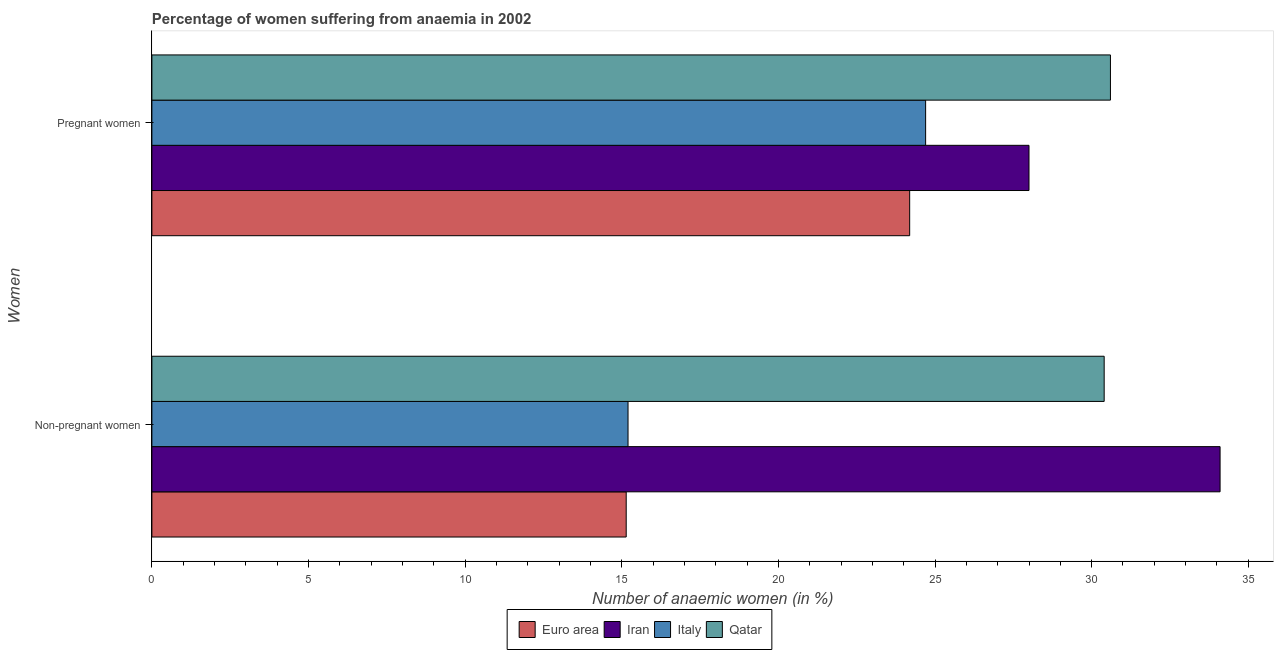How many different coloured bars are there?
Ensure brevity in your answer.  4. What is the label of the 2nd group of bars from the top?
Ensure brevity in your answer.  Non-pregnant women. What is the percentage of non-pregnant anaemic women in Italy?
Provide a short and direct response. 15.2. Across all countries, what is the maximum percentage of pregnant anaemic women?
Offer a terse response. 30.6. Across all countries, what is the minimum percentage of non-pregnant anaemic women?
Ensure brevity in your answer.  15.14. In which country was the percentage of non-pregnant anaemic women maximum?
Keep it short and to the point. Iran. In which country was the percentage of non-pregnant anaemic women minimum?
Provide a succinct answer. Euro area. What is the total percentage of non-pregnant anaemic women in the graph?
Give a very brief answer. 94.84. What is the difference between the percentage of non-pregnant anaemic women in Iran and that in Qatar?
Provide a succinct answer. 3.7. What is the difference between the percentage of non-pregnant anaemic women in Qatar and the percentage of pregnant anaemic women in Euro area?
Your answer should be compact. 6.21. What is the average percentage of non-pregnant anaemic women per country?
Offer a very short reply. 23.71. What is the difference between the percentage of non-pregnant anaemic women and percentage of pregnant anaemic women in Qatar?
Make the answer very short. -0.2. What is the ratio of the percentage of non-pregnant anaemic women in Euro area to that in Qatar?
Provide a succinct answer. 0.5. Is the percentage of pregnant anaemic women in Euro area less than that in Iran?
Your answer should be very brief. Yes. What does the 3rd bar from the top in Non-pregnant women represents?
Your answer should be very brief. Iran. What does the 2nd bar from the bottom in Non-pregnant women represents?
Offer a terse response. Iran. Are all the bars in the graph horizontal?
Provide a succinct answer. Yes. What is the difference between two consecutive major ticks on the X-axis?
Your answer should be compact. 5. Are the values on the major ticks of X-axis written in scientific E-notation?
Ensure brevity in your answer.  No. Where does the legend appear in the graph?
Ensure brevity in your answer.  Bottom center. How are the legend labels stacked?
Offer a very short reply. Horizontal. What is the title of the graph?
Your response must be concise. Percentage of women suffering from anaemia in 2002. Does "Mali" appear as one of the legend labels in the graph?
Ensure brevity in your answer.  No. What is the label or title of the X-axis?
Your answer should be compact. Number of anaemic women (in %). What is the label or title of the Y-axis?
Your response must be concise. Women. What is the Number of anaemic women (in %) of Euro area in Non-pregnant women?
Provide a succinct answer. 15.14. What is the Number of anaemic women (in %) of Iran in Non-pregnant women?
Give a very brief answer. 34.1. What is the Number of anaemic women (in %) of Italy in Non-pregnant women?
Your response must be concise. 15.2. What is the Number of anaemic women (in %) in Qatar in Non-pregnant women?
Your response must be concise. 30.4. What is the Number of anaemic women (in %) in Euro area in Pregnant women?
Your response must be concise. 24.19. What is the Number of anaemic women (in %) in Iran in Pregnant women?
Provide a succinct answer. 28. What is the Number of anaemic women (in %) of Italy in Pregnant women?
Ensure brevity in your answer.  24.7. What is the Number of anaemic women (in %) of Qatar in Pregnant women?
Make the answer very short. 30.6. Across all Women, what is the maximum Number of anaemic women (in %) in Euro area?
Provide a succinct answer. 24.19. Across all Women, what is the maximum Number of anaemic women (in %) in Iran?
Offer a very short reply. 34.1. Across all Women, what is the maximum Number of anaemic women (in %) in Italy?
Keep it short and to the point. 24.7. Across all Women, what is the maximum Number of anaemic women (in %) in Qatar?
Your response must be concise. 30.6. Across all Women, what is the minimum Number of anaemic women (in %) in Euro area?
Offer a very short reply. 15.14. Across all Women, what is the minimum Number of anaemic women (in %) of Iran?
Ensure brevity in your answer.  28. Across all Women, what is the minimum Number of anaemic women (in %) in Qatar?
Give a very brief answer. 30.4. What is the total Number of anaemic women (in %) of Euro area in the graph?
Provide a succinct answer. 39.33. What is the total Number of anaemic women (in %) in Iran in the graph?
Keep it short and to the point. 62.1. What is the total Number of anaemic women (in %) of Italy in the graph?
Offer a terse response. 39.9. What is the total Number of anaemic women (in %) of Qatar in the graph?
Your answer should be compact. 61. What is the difference between the Number of anaemic women (in %) in Euro area in Non-pregnant women and that in Pregnant women?
Ensure brevity in your answer.  -9.05. What is the difference between the Number of anaemic women (in %) of Italy in Non-pregnant women and that in Pregnant women?
Make the answer very short. -9.5. What is the difference between the Number of anaemic women (in %) in Qatar in Non-pregnant women and that in Pregnant women?
Your response must be concise. -0.2. What is the difference between the Number of anaemic women (in %) of Euro area in Non-pregnant women and the Number of anaemic women (in %) of Iran in Pregnant women?
Offer a very short reply. -12.86. What is the difference between the Number of anaemic women (in %) in Euro area in Non-pregnant women and the Number of anaemic women (in %) in Italy in Pregnant women?
Give a very brief answer. -9.56. What is the difference between the Number of anaemic women (in %) of Euro area in Non-pregnant women and the Number of anaemic women (in %) of Qatar in Pregnant women?
Provide a succinct answer. -15.46. What is the difference between the Number of anaemic women (in %) in Iran in Non-pregnant women and the Number of anaemic women (in %) in Qatar in Pregnant women?
Make the answer very short. 3.5. What is the difference between the Number of anaemic women (in %) in Italy in Non-pregnant women and the Number of anaemic women (in %) in Qatar in Pregnant women?
Give a very brief answer. -15.4. What is the average Number of anaemic women (in %) in Euro area per Women?
Your answer should be compact. 19.67. What is the average Number of anaemic women (in %) of Iran per Women?
Offer a very short reply. 31.05. What is the average Number of anaemic women (in %) of Italy per Women?
Give a very brief answer. 19.95. What is the average Number of anaemic women (in %) of Qatar per Women?
Provide a short and direct response. 30.5. What is the difference between the Number of anaemic women (in %) in Euro area and Number of anaemic women (in %) in Iran in Non-pregnant women?
Provide a short and direct response. -18.96. What is the difference between the Number of anaemic women (in %) of Euro area and Number of anaemic women (in %) of Italy in Non-pregnant women?
Offer a very short reply. -0.06. What is the difference between the Number of anaemic women (in %) in Euro area and Number of anaemic women (in %) in Qatar in Non-pregnant women?
Ensure brevity in your answer.  -15.26. What is the difference between the Number of anaemic women (in %) in Italy and Number of anaemic women (in %) in Qatar in Non-pregnant women?
Offer a very short reply. -15.2. What is the difference between the Number of anaemic women (in %) in Euro area and Number of anaemic women (in %) in Iran in Pregnant women?
Give a very brief answer. -3.81. What is the difference between the Number of anaemic women (in %) of Euro area and Number of anaemic women (in %) of Italy in Pregnant women?
Keep it short and to the point. -0.51. What is the difference between the Number of anaemic women (in %) in Euro area and Number of anaemic women (in %) in Qatar in Pregnant women?
Offer a very short reply. -6.41. What is the difference between the Number of anaemic women (in %) in Italy and Number of anaemic women (in %) in Qatar in Pregnant women?
Give a very brief answer. -5.9. What is the ratio of the Number of anaemic women (in %) of Euro area in Non-pregnant women to that in Pregnant women?
Make the answer very short. 0.63. What is the ratio of the Number of anaemic women (in %) of Iran in Non-pregnant women to that in Pregnant women?
Give a very brief answer. 1.22. What is the ratio of the Number of anaemic women (in %) in Italy in Non-pregnant women to that in Pregnant women?
Keep it short and to the point. 0.62. What is the difference between the highest and the second highest Number of anaemic women (in %) of Euro area?
Offer a very short reply. 9.05. What is the difference between the highest and the lowest Number of anaemic women (in %) in Euro area?
Give a very brief answer. 9.05. What is the difference between the highest and the lowest Number of anaemic women (in %) in Italy?
Your answer should be very brief. 9.5. What is the difference between the highest and the lowest Number of anaemic women (in %) of Qatar?
Your answer should be very brief. 0.2. 